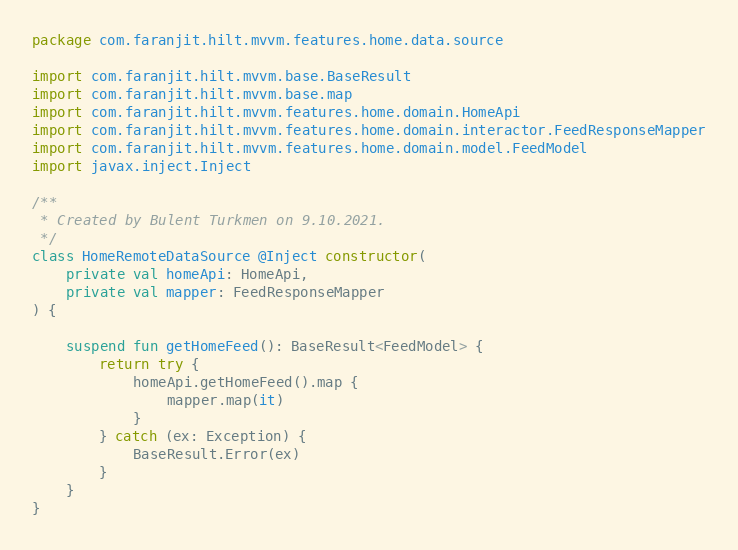<code> <loc_0><loc_0><loc_500><loc_500><_Kotlin_>package com.faranjit.hilt.mvvm.features.home.data.source

import com.faranjit.hilt.mvvm.base.BaseResult
import com.faranjit.hilt.mvvm.base.map
import com.faranjit.hilt.mvvm.features.home.domain.HomeApi
import com.faranjit.hilt.mvvm.features.home.domain.interactor.FeedResponseMapper
import com.faranjit.hilt.mvvm.features.home.domain.model.FeedModel
import javax.inject.Inject

/**
 * Created by Bulent Turkmen on 9.10.2021.
 */
class HomeRemoteDataSource @Inject constructor(
    private val homeApi: HomeApi,
    private val mapper: FeedResponseMapper
) {

    suspend fun getHomeFeed(): BaseResult<FeedModel> {
        return try {
            homeApi.getHomeFeed().map {
                mapper.map(it)
            }
        } catch (ex: Exception) {
            BaseResult.Error(ex)
        }
    }
}</code> 